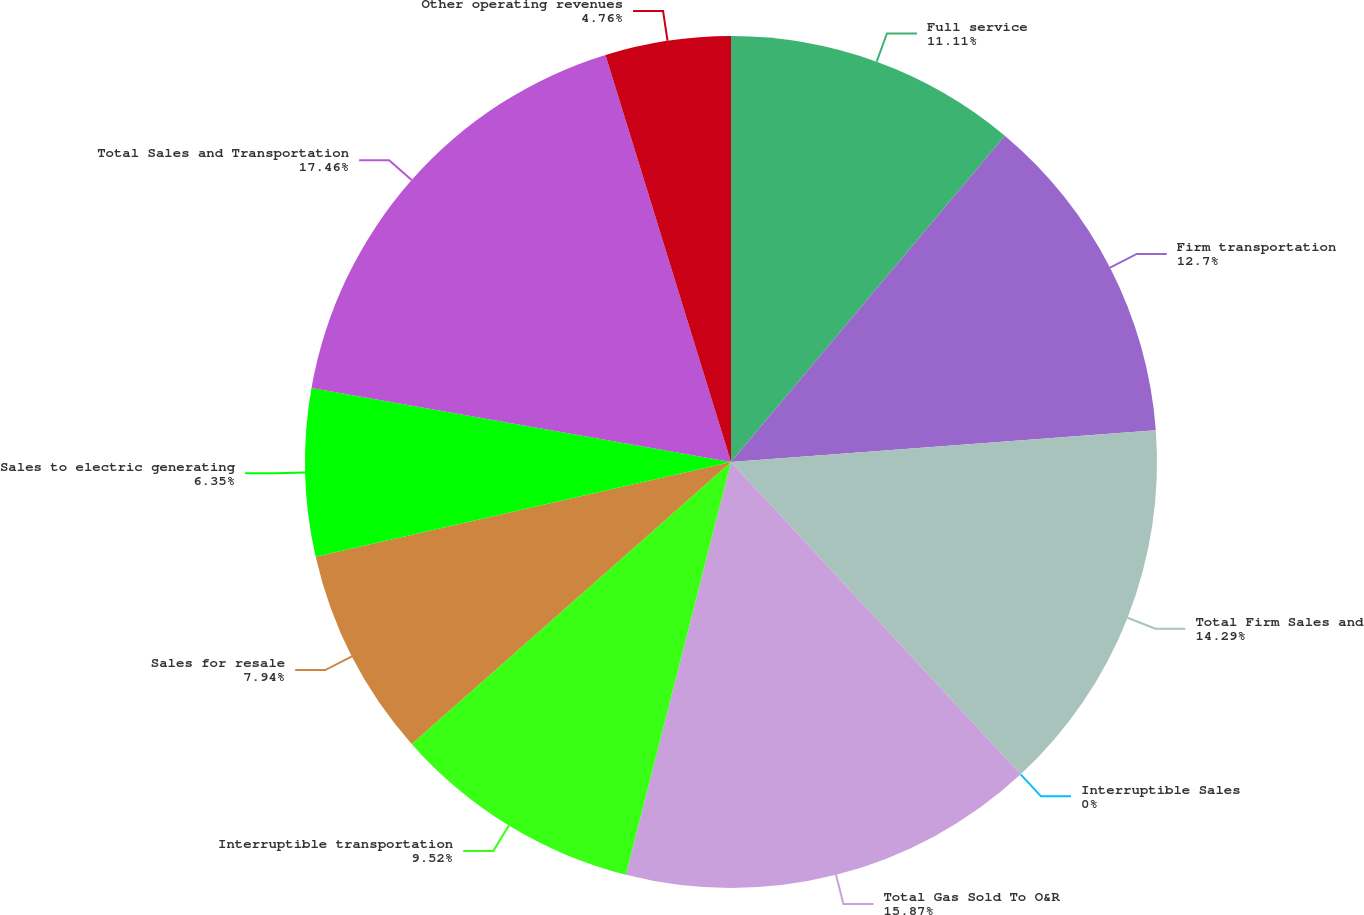<chart> <loc_0><loc_0><loc_500><loc_500><pie_chart><fcel>Full service<fcel>Firm transportation<fcel>Total Firm Sales and<fcel>Interruptible Sales<fcel>Total Gas Sold To O&R<fcel>Interruptible transportation<fcel>Sales for resale<fcel>Sales to electric generating<fcel>Total Sales and Transportation<fcel>Other operating revenues<nl><fcel>11.11%<fcel>12.7%<fcel>14.29%<fcel>0.0%<fcel>15.87%<fcel>9.52%<fcel>7.94%<fcel>6.35%<fcel>17.46%<fcel>4.76%<nl></chart> 